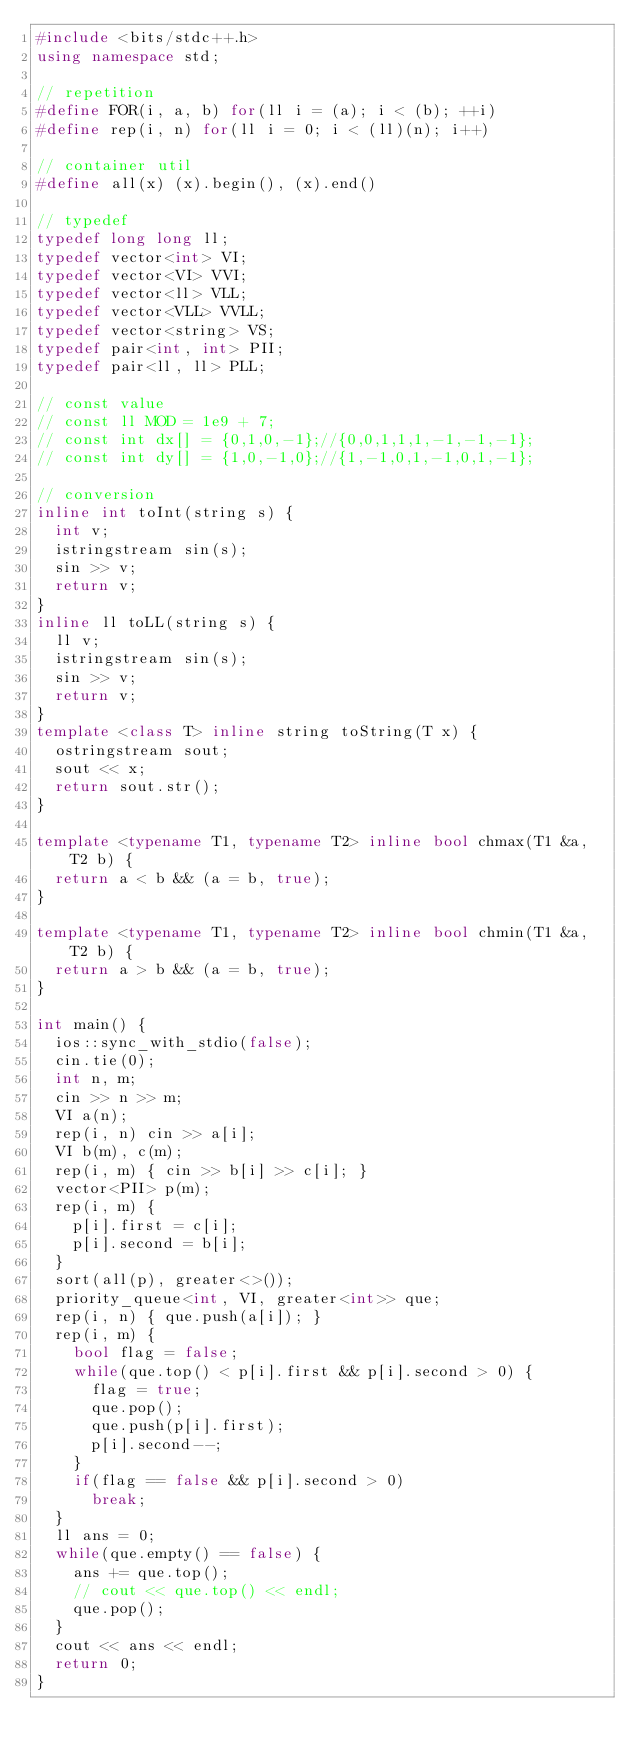<code> <loc_0><loc_0><loc_500><loc_500><_C++_>#include <bits/stdc++.h>
using namespace std;

// repetition
#define FOR(i, a, b) for(ll i = (a); i < (b); ++i)
#define rep(i, n) for(ll i = 0; i < (ll)(n); i++)

// container util
#define all(x) (x).begin(), (x).end()

// typedef
typedef long long ll;
typedef vector<int> VI;
typedef vector<VI> VVI;
typedef vector<ll> VLL;
typedef vector<VLL> VVLL;
typedef vector<string> VS;
typedef pair<int, int> PII;
typedef pair<ll, ll> PLL;

// const value
// const ll MOD = 1e9 + 7;
// const int dx[] = {0,1,0,-1};//{0,0,1,1,1,-1,-1,-1};
// const int dy[] = {1,0,-1,0};//{1,-1,0,1,-1,0,1,-1};

// conversion
inline int toInt(string s) {
  int v;
  istringstream sin(s);
  sin >> v;
  return v;
}
inline ll toLL(string s) {
  ll v;
  istringstream sin(s);
  sin >> v;
  return v;
}
template <class T> inline string toString(T x) {
  ostringstream sout;
  sout << x;
  return sout.str();
}

template <typename T1, typename T2> inline bool chmax(T1 &a, T2 b) {
  return a < b && (a = b, true);
}

template <typename T1, typename T2> inline bool chmin(T1 &a, T2 b) {
  return a > b && (a = b, true);
}

int main() {
  ios::sync_with_stdio(false);
  cin.tie(0);
  int n, m;
  cin >> n >> m;
  VI a(n);
  rep(i, n) cin >> a[i];
  VI b(m), c(m);
  rep(i, m) { cin >> b[i] >> c[i]; }
  vector<PII> p(m);
  rep(i, m) {
    p[i].first = c[i];
    p[i].second = b[i];
  }
  sort(all(p), greater<>());
  priority_queue<int, VI, greater<int>> que;
  rep(i, n) { que.push(a[i]); }
  rep(i, m) {
    bool flag = false;
    while(que.top() < p[i].first && p[i].second > 0) {
      flag = true;
      que.pop();
      que.push(p[i].first);
      p[i].second--;
    }
    if(flag == false && p[i].second > 0)
      break;
  }
  ll ans = 0;
  while(que.empty() == false) {
    ans += que.top();
    // cout << que.top() << endl;
    que.pop();
  }
  cout << ans << endl;
  return 0;
}
</code> 